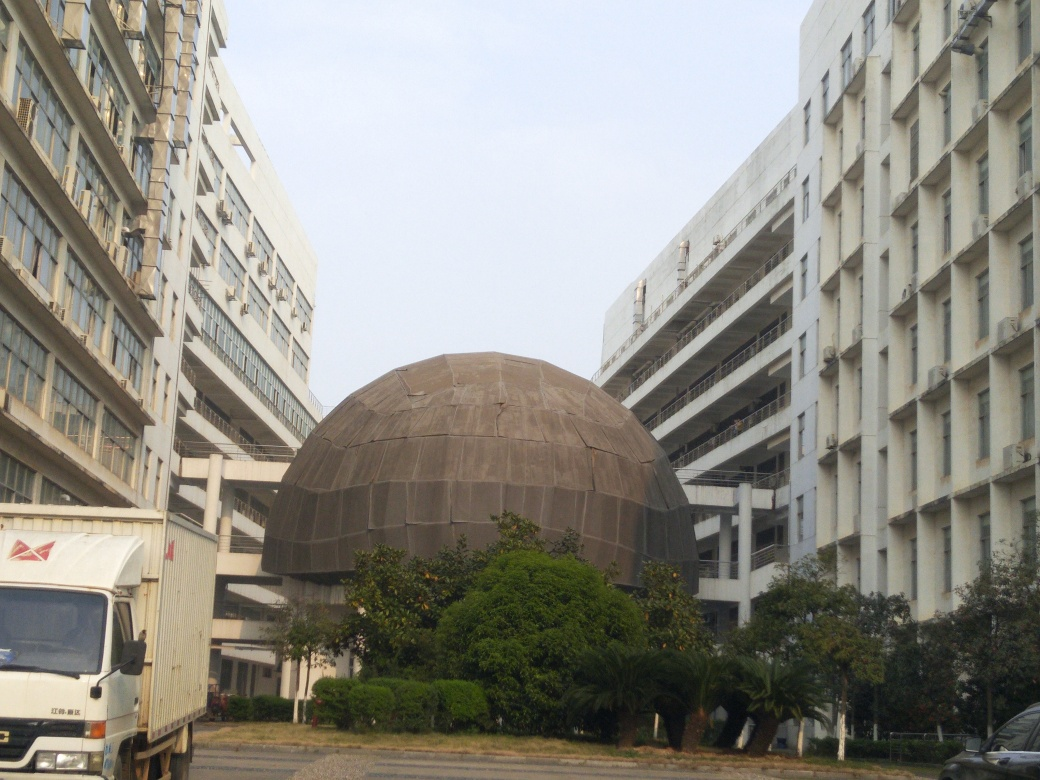What time of day does this image seem to have been taken? Based on the lighting and lack of shadows in the image, it appears to have been taken on an overcast day or during the early morning or late afternoon hours when the sun is not as intense. The soft, diffused light suggests that direct sunlight was not present at the time the photo was captured. 